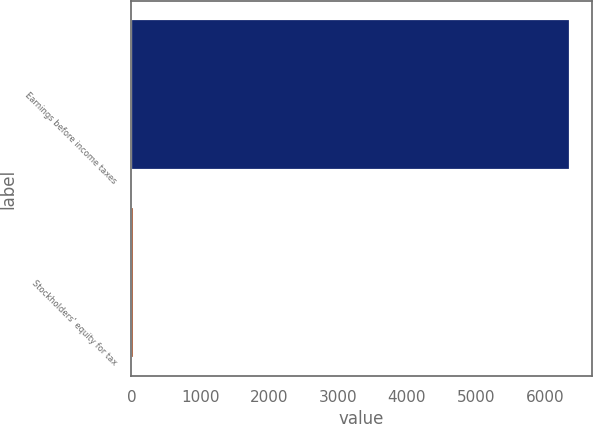Convert chart. <chart><loc_0><loc_0><loc_500><loc_500><bar_chart><fcel>Earnings before income taxes<fcel>Stockholders' equity for tax<nl><fcel>6366<fcel>31<nl></chart> 